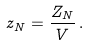Convert formula to latex. <formula><loc_0><loc_0><loc_500><loc_500>z _ { N } = \frac { Z _ { N } } { V } \, .</formula> 